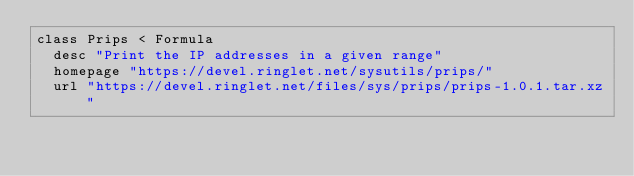Convert code to text. <code><loc_0><loc_0><loc_500><loc_500><_Ruby_>class Prips < Formula
  desc "Print the IP addresses in a given range"
  homepage "https://devel.ringlet.net/sysutils/prips/"
  url "https://devel.ringlet.net/files/sys/prips/prips-1.0.1.tar.xz"</code> 